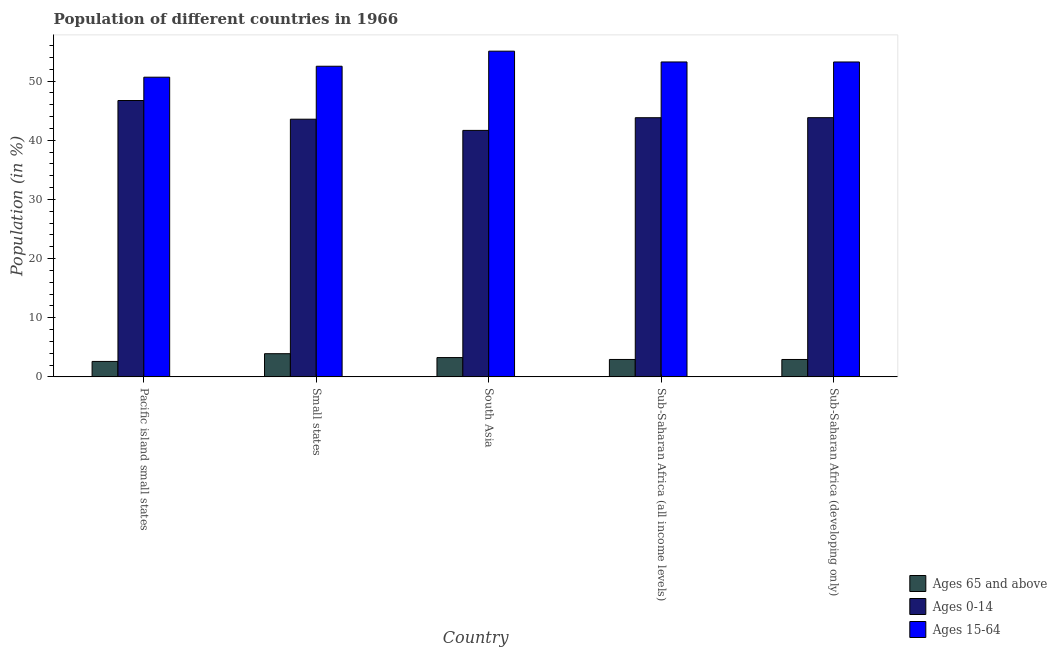Are the number of bars per tick equal to the number of legend labels?
Your answer should be very brief. Yes. Are the number of bars on each tick of the X-axis equal?
Your answer should be very brief. Yes. How many bars are there on the 2nd tick from the right?
Keep it short and to the point. 3. What is the label of the 4th group of bars from the left?
Make the answer very short. Sub-Saharan Africa (all income levels). What is the percentage of population within the age-group 0-14 in Sub-Saharan Africa (all income levels)?
Make the answer very short. 43.81. Across all countries, what is the maximum percentage of population within the age-group 15-64?
Provide a short and direct response. 55.07. Across all countries, what is the minimum percentage of population within the age-group of 65 and above?
Your answer should be compact. 2.61. In which country was the percentage of population within the age-group of 65 and above maximum?
Provide a short and direct response. Small states. In which country was the percentage of population within the age-group 0-14 minimum?
Your answer should be very brief. South Asia. What is the total percentage of population within the age-group 0-14 in the graph?
Make the answer very short. 219.59. What is the difference between the percentage of population within the age-group 15-64 in Pacific island small states and that in Sub-Saharan Africa (developing only)?
Keep it short and to the point. -2.57. What is the difference between the percentage of population within the age-group 15-64 in Sub-Saharan Africa (all income levels) and the percentage of population within the age-group of 65 and above in South Asia?
Your answer should be compact. 49.98. What is the average percentage of population within the age-group 0-14 per country?
Your answer should be very brief. 43.92. What is the difference between the percentage of population within the age-group 0-14 and percentage of population within the age-group 15-64 in Sub-Saharan Africa (developing only)?
Provide a succinct answer. -9.42. What is the ratio of the percentage of population within the age-group of 65 and above in Small states to that in Sub-Saharan Africa (developing only)?
Give a very brief answer. 1.33. Is the difference between the percentage of population within the age-group of 65 and above in Pacific island small states and Sub-Saharan Africa (all income levels) greater than the difference between the percentage of population within the age-group 15-64 in Pacific island small states and Sub-Saharan Africa (all income levels)?
Offer a terse response. Yes. What is the difference between the highest and the second highest percentage of population within the age-group 0-14?
Make the answer very short. 2.9. What is the difference between the highest and the lowest percentage of population within the age-group 15-64?
Your answer should be compact. 4.4. What does the 3rd bar from the left in Sub-Saharan Africa (developing only) represents?
Your answer should be very brief. Ages 15-64. What does the 3rd bar from the right in Sub-Saharan Africa (developing only) represents?
Your answer should be compact. Ages 65 and above. Is it the case that in every country, the sum of the percentage of population within the age-group of 65 and above and percentage of population within the age-group 0-14 is greater than the percentage of population within the age-group 15-64?
Make the answer very short. No. How many bars are there?
Make the answer very short. 15. Are all the bars in the graph horizontal?
Keep it short and to the point. No. Where does the legend appear in the graph?
Provide a succinct answer. Bottom right. How are the legend labels stacked?
Provide a succinct answer. Vertical. What is the title of the graph?
Offer a terse response. Population of different countries in 1966. What is the Population (in %) in Ages 65 and above in Pacific island small states?
Offer a very short reply. 2.61. What is the Population (in %) in Ages 0-14 in Pacific island small states?
Make the answer very short. 46.72. What is the Population (in %) in Ages 15-64 in Pacific island small states?
Give a very brief answer. 50.66. What is the Population (in %) in Ages 65 and above in Small states?
Keep it short and to the point. 3.92. What is the Population (in %) of Ages 0-14 in Small states?
Offer a terse response. 43.56. What is the Population (in %) of Ages 15-64 in Small states?
Provide a short and direct response. 52.52. What is the Population (in %) in Ages 65 and above in South Asia?
Your response must be concise. 3.26. What is the Population (in %) in Ages 0-14 in South Asia?
Offer a very short reply. 41.67. What is the Population (in %) in Ages 15-64 in South Asia?
Provide a succinct answer. 55.07. What is the Population (in %) of Ages 65 and above in Sub-Saharan Africa (all income levels)?
Give a very brief answer. 2.94. What is the Population (in %) of Ages 0-14 in Sub-Saharan Africa (all income levels)?
Provide a short and direct response. 43.81. What is the Population (in %) in Ages 15-64 in Sub-Saharan Africa (all income levels)?
Your answer should be very brief. 53.24. What is the Population (in %) of Ages 65 and above in Sub-Saharan Africa (developing only)?
Your answer should be very brief. 2.94. What is the Population (in %) of Ages 0-14 in Sub-Saharan Africa (developing only)?
Offer a terse response. 43.82. What is the Population (in %) of Ages 15-64 in Sub-Saharan Africa (developing only)?
Make the answer very short. 53.24. Across all countries, what is the maximum Population (in %) of Ages 65 and above?
Offer a very short reply. 3.92. Across all countries, what is the maximum Population (in %) in Ages 0-14?
Your response must be concise. 46.72. Across all countries, what is the maximum Population (in %) of Ages 15-64?
Your response must be concise. 55.07. Across all countries, what is the minimum Population (in %) of Ages 65 and above?
Your answer should be compact. 2.61. Across all countries, what is the minimum Population (in %) in Ages 0-14?
Ensure brevity in your answer.  41.67. Across all countries, what is the minimum Population (in %) of Ages 15-64?
Your answer should be very brief. 50.66. What is the total Population (in %) of Ages 65 and above in the graph?
Your response must be concise. 15.68. What is the total Population (in %) of Ages 0-14 in the graph?
Your response must be concise. 219.59. What is the total Population (in %) of Ages 15-64 in the graph?
Offer a very short reply. 264.73. What is the difference between the Population (in %) of Ages 65 and above in Pacific island small states and that in Small states?
Keep it short and to the point. -1.31. What is the difference between the Population (in %) in Ages 0-14 in Pacific island small states and that in Small states?
Ensure brevity in your answer.  3.16. What is the difference between the Population (in %) in Ages 15-64 in Pacific island small states and that in Small states?
Offer a very short reply. -1.85. What is the difference between the Population (in %) in Ages 65 and above in Pacific island small states and that in South Asia?
Provide a succinct answer. -0.65. What is the difference between the Population (in %) of Ages 0-14 in Pacific island small states and that in South Asia?
Provide a short and direct response. 5.05. What is the difference between the Population (in %) in Ages 15-64 in Pacific island small states and that in South Asia?
Make the answer very short. -4.4. What is the difference between the Population (in %) in Ages 65 and above in Pacific island small states and that in Sub-Saharan Africa (all income levels)?
Offer a terse response. -0.33. What is the difference between the Population (in %) in Ages 0-14 in Pacific island small states and that in Sub-Saharan Africa (all income levels)?
Your response must be concise. 2.91. What is the difference between the Population (in %) of Ages 15-64 in Pacific island small states and that in Sub-Saharan Africa (all income levels)?
Give a very brief answer. -2.58. What is the difference between the Population (in %) of Ages 65 and above in Pacific island small states and that in Sub-Saharan Africa (developing only)?
Keep it short and to the point. -0.33. What is the difference between the Population (in %) of Ages 0-14 in Pacific island small states and that in Sub-Saharan Africa (developing only)?
Make the answer very short. 2.9. What is the difference between the Population (in %) in Ages 15-64 in Pacific island small states and that in Sub-Saharan Africa (developing only)?
Offer a terse response. -2.57. What is the difference between the Population (in %) of Ages 65 and above in Small states and that in South Asia?
Offer a terse response. 0.66. What is the difference between the Population (in %) in Ages 0-14 in Small states and that in South Asia?
Give a very brief answer. 1.89. What is the difference between the Population (in %) of Ages 15-64 in Small states and that in South Asia?
Provide a short and direct response. -2.55. What is the difference between the Population (in %) in Ages 65 and above in Small states and that in Sub-Saharan Africa (all income levels)?
Offer a terse response. 0.97. What is the difference between the Population (in %) of Ages 0-14 in Small states and that in Sub-Saharan Africa (all income levels)?
Provide a short and direct response. -0.25. What is the difference between the Population (in %) of Ages 15-64 in Small states and that in Sub-Saharan Africa (all income levels)?
Keep it short and to the point. -0.72. What is the difference between the Population (in %) in Ages 65 and above in Small states and that in Sub-Saharan Africa (developing only)?
Provide a succinct answer. 0.98. What is the difference between the Population (in %) of Ages 0-14 in Small states and that in Sub-Saharan Africa (developing only)?
Offer a terse response. -0.26. What is the difference between the Population (in %) in Ages 15-64 in Small states and that in Sub-Saharan Africa (developing only)?
Provide a short and direct response. -0.72. What is the difference between the Population (in %) in Ages 65 and above in South Asia and that in Sub-Saharan Africa (all income levels)?
Offer a terse response. 0.32. What is the difference between the Population (in %) in Ages 0-14 in South Asia and that in Sub-Saharan Africa (all income levels)?
Your response must be concise. -2.14. What is the difference between the Population (in %) in Ages 15-64 in South Asia and that in Sub-Saharan Africa (all income levels)?
Provide a short and direct response. 1.83. What is the difference between the Population (in %) in Ages 65 and above in South Asia and that in Sub-Saharan Africa (developing only)?
Make the answer very short. 0.32. What is the difference between the Population (in %) in Ages 0-14 in South Asia and that in Sub-Saharan Africa (developing only)?
Offer a very short reply. -2.15. What is the difference between the Population (in %) in Ages 15-64 in South Asia and that in Sub-Saharan Africa (developing only)?
Give a very brief answer. 1.83. What is the difference between the Population (in %) of Ages 65 and above in Sub-Saharan Africa (all income levels) and that in Sub-Saharan Africa (developing only)?
Provide a succinct answer. 0. What is the difference between the Population (in %) in Ages 0-14 in Sub-Saharan Africa (all income levels) and that in Sub-Saharan Africa (developing only)?
Offer a very short reply. -0.01. What is the difference between the Population (in %) in Ages 15-64 in Sub-Saharan Africa (all income levels) and that in Sub-Saharan Africa (developing only)?
Ensure brevity in your answer.  0. What is the difference between the Population (in %) of Ages 65 and above in Pacific island small states and the Population (in %) of Ages 0-14 in Small states?
Keep it short and to the point. -40.95. What is the difference between the Population (in %) in Ages 65 and above in Pacific island small states and the Population (in %) in Ages 15-64 in Small states?
Your answer should be compact. -49.9. What is the difference between the Population (in %) of Ages 0-14 in Pacific island small states and the Population (in %) of Ages 15-64 in Small states?
Your response must be concise. -5.79. What is the difference between the Population (in %) of Ages 65 and above in Pacific island small states and the Population (in %) of Ages 0-14 in South Asia?
Offer a very short reply. -39.06. What is the difference between the Population (in %) in Ages 65 and above in Pacific island small states and the Population (in %) in Ages 15-64 in South Asia?
Offer a terse response. -52.45. What is the difference between the Population (in %) of Ages 0-14 in Pacific island small states and the Population (in %) of Ages 15-64 in South Asia?
Make the answer very short. -8.34. What is the difference between the Population (in %) of Ages 65 and above in Pacific island small states and the Population (in %) of Ages 0-14 in Sub-Saharan Africa (all income levels)?
Your answer should be compact. -41.2. What is the difference between the Population (in %) in Ages 65 and above in Pacific island small states and the Population (in %) in Ages 15-64 in Sub-Saharan Africa (all income levels)?
Your answer should be compact. -50.63. What is the difference between the Population (in %) of Ages 0-14 in Pacific island small states and the Population (in %) of Ages 15-64 in Sub-Saharan Africa (all income levels)?
Keep it short and to the point. -6.52. What is the difference between the Population (in %) of Ages 65 and above in Pacific island small states and the Population (in %) of Ages 0-14 in Sub-Saharan Africa (developing only)?
Offer a very short reply. -41.21. What is the difference between the Population (in %) of Ages 65 and above in Pacific island small states and the Population (in %) of Ages 15-64 in Sub-Saharan Africa (developing only)?
Keep it short and to the point. -50.63. What is the difference between the Population (in %) in Ages 0-14 in Pacific island small states and the Population (in %) in Ages 15-64 in Sub-Saharan Africa (developing only)?
Make the answer very short. -6.51. What is the difference between the Population (in %) in Ages 65 and above in Small states and the Population (in %) in Ages 0-14 in South Asia?
Your answer should be very brief. -37.75. What is the difference between the Population (in %) of Ages 65 and above in Small states and the Population (in %) of Ages 15-64 in South Asia?
Provide a short and direct response. -51.15. What is the difference between the Population (in %) in Ages 0-14 in Small states and the Population (in %) in Ages 15-64 in South Asia?
Provide a short and direct response. -11.5. What is the difference between the Population (in %) in Ages 65 and above in Small states and the Population (in %) in Ages 0-14 in Sub-Saharan Africa (all income levels)?
Your response must be concise. -39.9. What is the difference between the Population (in %) of Ages 65 and above in Small states and the Population (in %) of Ages 15-64 in Sub-Saharan Africa (all income levels)?
Your answer should be compact. -49.32. What is the difference between the Population (in %) in Ages 0-14 in Small states and the Population (in %) in Ages 15-64 in Sub-Saharan Africa (all income levels)?
Give a very brief answer. -9.68. What is the difference between the Population (in %) of Ages 65 and above in Small states and the Population (in %) of Ages 0-14 in Sub-Saharan Africa (developing only)?
Give a very brief answer. -39.9. What is the difference between the Population (in %) of Ages 65 and above in Small states and the Population (in %) of Ages 15-64 in Sub-Saharan Africa (developing only)?
Offer a very short reply. -49.32. What is the difference between the Population (in %) of Ages 0-14 in Small states and the Population (in %) of Ages 15-64 in Sub-Saharan Africa (developing only)?
Keep it short and to the point. -9.67. What is the difference between the Population (in %) of Ages 65 and above in South Asia and the Population (in %) of Ages 0-14 in Sub-Saharan Africa (all income levels)?
Offer a terse response. -40.55. What is the difference between the Population (in %) in Ages 65 and above in South Asia and the Population (in %) in Ages 15-64 in Sub-Saharan Africa (all income levels)?
Offer a very short reply. -49.98. What is the difference between the Population (in %) in Ages 0-14 in South Asia and the Population (in %) in Ages 15-64 in Sub-Saharan Africa (all income levels)?
Keep it short and to the point. -11.57. What is the difference between the Population (in %) of Ages 65 and above in South Asia and the Population (in %) of Ages 0-14 in Sub-Saharan Africa (developing only)?
Ensure brevity in your answer.  -40.56. What is the difference between the Population (in %) in Ages 65 and above in South Asia and the Population (in %) in Ages 15-64 in Sub-Saharan Africa (developing only)?
Your response must be concise. -49.98. What is the difference between the Population (in %) of Ages 0-14 in South Asia and the Population (in %) of Ages 15-64 in Sub-Saharan Africa (developing only)?
Offer a terse response. -11.57. What is the difference between the Population (in %) in Ages 65 and above in Sub-Saharan Africa (all income levels) and the Population (in %) in Ages 0-14 in Sub-Saharan Africa (developing only)?
Ensure brevity in your answer.  -40.88. What is the difference between the Population (in %) in Ages 65 and above in Sub-Saharan Africa (all income levels) and the Population (in %) in Ages 15-64 in Sub-Saharan Africa (developing only)?
Ensure brevity in your answer.  -50.29. What is the difference between the Population (in %) of Ages 0-14 in Sub-Saharan Africa (all income levels) and the Population (in %) of Ages 15-64 in Sub-Saharan Africa (developing only)?
Give a very brief answer. -9.42. What is the average Population (in %) of Ages 65 and above per country?
Provide a succinct answer. 3.14. What is the average Population (in %) in Ages 0-14 per country?
Offer a very short reply. 43.92. What is the average Population (in %) of Ages 15-64 per country?
Make the answer very short. 52.95. What is the difference between the Population (in %) in Ages 65 and above and Population (in %) in Ages 0-14 in Pacific island small states?
Your answer should be very brief. -44.11. What is the difference between the Population (in %) of Ages 65 and above and Population (in %) of Ages 15-64 in Pacific island small states?
Your response must be concise. -48.05. What is the difference between the Population (in %) in Ages 0-14 and Population (in %) in Ages 15-64 in Pacific island small states?
Offer a very short reply. -3.94. What is the difference between the Population (in %) of Ages 65 and above and Population (in %) of Ages 0-14 in Small states?
Your answer should be compact. -39.65. What is the difference between the Population (in %) in Ages 65 and above and Population (in %) in Ages 15-64 in Small states?
Keep it short and to the point. -48.6. What is the difference between the Population (in %) in Ages 0-14 and Population (in %) in Ages 15-64 in Small states?
Keep it short and to the point. -8.95. What is the difference between the Population (in %) of Ages 65 and above and Population (in %) of Ages 0-14 in South Asia?
Your response must be concise. -38.41. What is the difference between the Population (in %) in Ages 65 and above and Population (in %) in Ages 15-64 in South Asia?
Offer a terse response. -51.8. What is the difference between the Population (in %) in Ages 0-14 and Population (in %) in Ages 15-64 in South Asia?
Offer a very short reply. -13.4. What is the difference between the Population (in %) in Ages 65 and above and Population (in %) in Ages 0-14 in Sub-Saharan Africa (all income levels)?
Provide a short and direct response. -40.87. What is the difference between the Population (in %) in Ages 65 and above and Population (in %) in Ages 15-64 in Sub-Saharan Africa (all income levels)?
Your answer should be very brief. -50.3. What is the difference between the Population (in %) in Ages 0-14 and Population (in %) in Ages 15-64 in Sub-Saharan Africa (all income levels)?
Provide a succinct answer. -9.43. What is the difference between the Population (in %) of Ages 65 and above and Population (in %) of Ages 0-14 in Sub-Saharan Africa (developing only)?
Keep it short and to the point. -40.88. What is the difference between the Population (in %) in Ages 65 and above and Population (in %) in Ages 15-64 in Sub-Saharan Africa (developing only)?
Offer a terse response. -50.3. What is the difference between the Population (in %) in Ages 0-14 and Population (in %) in Ages 15-64 in Sub-Saharan Africa (developing only)?
Make the answer very short. -9.42. What is the ratio of the Population (in %) in Ages 65 and above in Pacific island small states to that in Small states?
Keep it short and to the point. 0.67. What is the ratio of the Population (in %) of Ages 0-14 in Pacific island small states to that in Small states?
Offer a terse response. 1.07. What is the ratio of the Population (in %) of Ages 15-64 in Pacific island small states to that in Small states?
Keep it short and to the point. 0.96. What is the ratio of the Population (in %) in Ages 65 and above in Pacific island small states to that in South Asia?
Make the answer very short. 0.8. What is the ratio of the Population (in %) in Ages 0-14 in Pacific island small states to that in South Asia?
Your response must be concise. 1.12. What is the ratio of the Population (in %) in Ages 15-64 in Pacific island small states to that in South Asia?
Provide a short and direct response. 0.92. What is the ratio of the Population (in %) in Ages 65 and above in Pacific island small states to that in Sub-Saharan Africa (all income levels)?
Provide a succinct answer. 0.89. What is the ratio of the Population (in %) in Ages 0-14 in Pacific island small states to that in Sub-Saharan Africa (all income levels)?
Give a very brief answer. 1.07. What is the ratio of the Population (in %) of Ages 15-64 in Pacific island small states to that in Sub-Saharan Africa (all income levels)?
Your answer should be compact. 0.95. What is the ratio of the Population (in %) in Ages 65 and above in Pacific island small states to that in Sub-Saharan Africa (developing only)?
Your answer should be compact. 0.89. What is the ratio of the Population (in %) in Ages 0-14 in Pacific island small states to that in Sub-Saharan Africa (developing only)?
Give a very brief answer. 1.07. What is the ratio of the Population (in %) in Ages 15-64 in Pacific island small states to that in Sub-Saharan Africa (developing only)?
Your answer should be very brief. 0.95. What is the ratio of the Population (in %) of Ages 65 and above in Small states to that in South Asia?
Offer a terse response. 1.2. What is the ratio of the Population (in %) in Ages 0-14 in Small states to that in South Asia?
Offer a terse response. 1.05. What is the ratio of the Population (in %) of Ages 15-64 in Small states to that in South Asia?
Your response must be concise. 0.95. What is the ratio of the Population (in %) of Ages 65 and above in Small states to that in Sub-Saharan Africa (all income levels)?
Your answer should be very brief. 1.33. What is the ratio of the Population (in %) in Ages 15-64 in Small states to that in Sub-Saharan Africa (all income levels)?
Give a very brief answer. 0.99. What is the ratio of the Population (in %) of Ages 65 and above in Small states to that in Sub-Saharan Africa (developing only)?
Offer a very short reply. 1.33. What is the ratio of the Population (in %) in Ages 0-14 in Small states to that in Sub-Saharan Africa (developing only)?
Your response must be concise. 0.99. What is the ratio of the Population (in %) in Ages 15-64 in Small states to that in Sub-Saharan Africa (developing only)?
Offer a very short reply. 0.99. What is the ratio of the Population (in %) in Ages 65 and above in South Asia to that in Sub-Saharan Africa (all income levels)?
Keep it short and to the point. 1.11. What is the ratio of the Population (in %) of Ages 0-14 in South Asia to that in Sub-Saharan Africa (all income levels)?
Keep it short and to the point. 0.95. What is the ratio of the Population (in %) of Ages 15-64 in South Asia to that in Sub-Saharan Africa (all income levels)?
Make the answer very short. 1.03. What is the ratio of the Population (in %) in Ages 65 and above in South Asia to that in Sub-Saharan Africa (developing only)?
Make the answer very short. 1.11. What is the ratio of the Population (in %) in Ages 0-14 in South Asia to that in Sub-Saharan Africa (developing only)?
Ensure brevity in your answer.  0.95. What is the ratio of the Population (in %) of Ages 15-64 in South Asia to that in Sub-Saharan Africa (developing only)?
Your response must be concise. 1.03. What is the ratio of the Population (in %) in Ages 65 and above in Sub-Saharan Africa (all income levels) to that in Sub-Saharan Africa (developing only)?
Offer a very short reply. 1. What is the ratio of the Population (in %) of Ages 0-14 in Sub-Saharan Africa (all income levels) to that in Sub-Saharan Africa (developing only)?
Offer a terse response. 1. What is the difference between the highest and the second highest Population (in %) of Ages 65 and above?
Make the answer very short. 0.66. What is the difference between the highest and the second highest Population (in %) in Ages 0-14?
Offer a terse response. 2.9. What is the difference between the highest and the second highest Population (in %) in Ages 15-64?
Your answer should be very brief. 1.83. What is the difference between the highest and the lowest Population (in %) in Ages 65 and above?
Offer a very short reply. 1.31. What is the difference between the highest and the lowest Population (in %) of Ages 0-14?
Keep it short and to the point. 5.05. What is the difference between the highest and the lowest Population (in %) of Ages 15-64?
Offer a terse response. 4.4. 